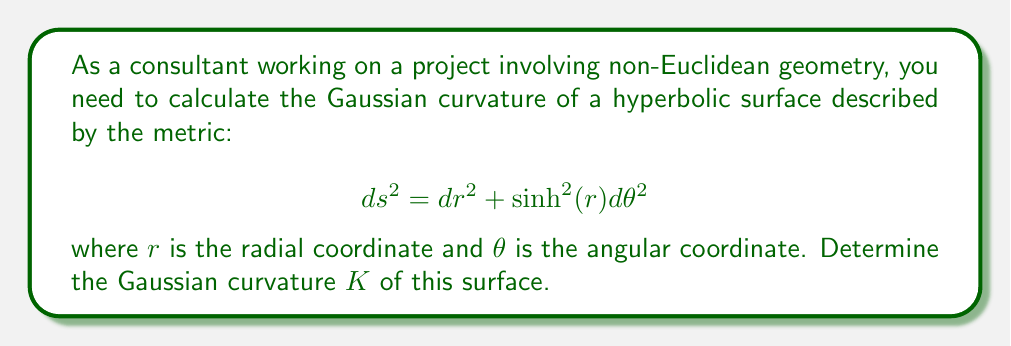Show me your answer to this math problem. To calculate the Gaussian curvature of this hyperbolic surface, we'll use the Gaussian curvature formula for a surface described in polar coordinates:

$$K = -\frac{1}{f(r)} \frac{d^2f(r)}{dr^2}$$

where $f(r)$ is the coefficient of $d\theta^2$ in the metric.

Step 1: Identify $f(r)$ from the given metric.
$f(r) = \sinh^2(r)$

Step 2: Calculate the second derivative of $f(r)$ with respect to $r$.
$$\frac{d}{dr}f(r) = 2\sinh(r)\cosh(r)$$
$$\frac{d^2}{dr^2}f(r) = 2(\cosh^2(r) + \sinh^2(r))$$

Step 3: Apply the Gaussian curvature formula.
$$K = -\frac{1}{\sinh^2(r)} \cdot 2(\cosh^2(r) + \sinh^2(r))$$

Step 4: Simplify using the hyperbolic identity $\cosh^2(r) - \sinh^2(r) = 1$.
$$K = -\frac{2(\cosh^2(r) + \sinh^2(r))}{\sinh^2(r)}$$
$$K = -\frac{2(\sinh^2(r) + 1 + \sinh^2(r))}{\sinh^2(r)}$$
$$K = -\frac{2(2\sinh^2(r) + 1)}{\sinh^2(r)}$$
$$K = -\frac{4\sinh^2(r) + 2}{\sinh^2(r)}$$
$$K = -4 - \frac{2}{\sinh^2(r)}$$

Step 5: Further simplify to get the final result.
$$K = -\left(1 + \frac{1}{\sinh^2(r)}\right)$$
Answer: $K = -\left(1 + \frac{1}{\sinh^2(r)}\right)$ 